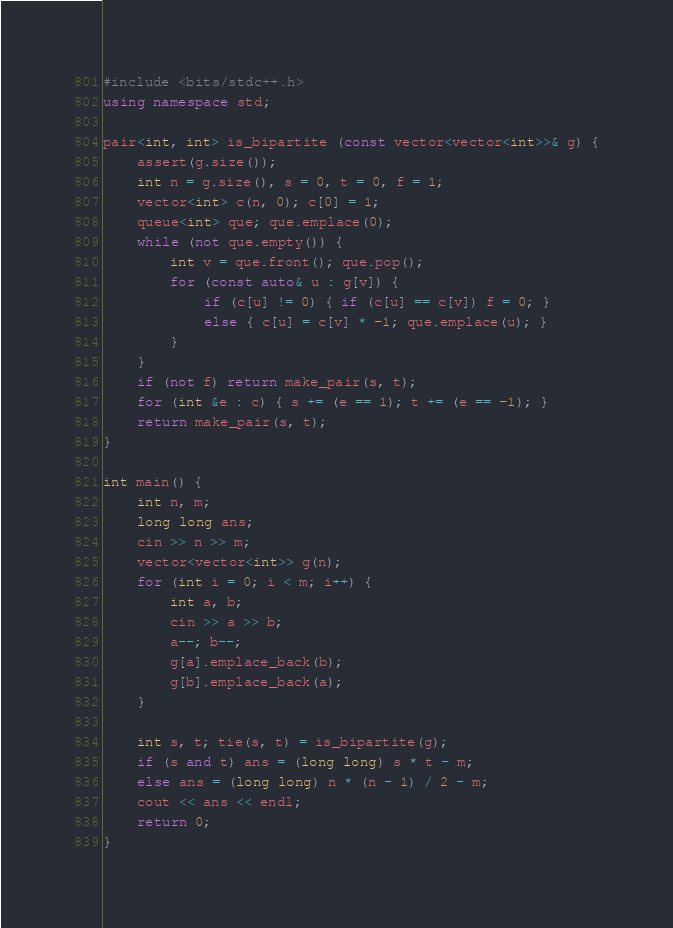Convert code to text. <code><loc_0><loc_0><loc_500><loc_500><_C++_>#include <bits/stdc++.h>
using namespace std;

pair<int, int> is_bipartite (const vector<vector<int>>& g) {
    assert(g.size());
    int n = g.size(), s = 0, t = 0, f = 1;
    vector<int> c(n, 0); c[0] = 1;
    queue<int> que; que.emplace(0);
    while (not que.empty()) {
        int v = que.front(); que.pop();
        for (const auto& u : g[v]) {
            if (c[u] != 0) { if (c[u] == c[v]) f = 0; }
            else { c[u] = c[v] * -1; que.emplace(u); }
        }
    }
    if (not f) return make_pair(s, t);
    for (int &e : c) { s += (e == 1); t += (e == -1); }
    return make_pair(s, t);
}

int main() {
    int n, m;
    long long ans;
    cin >> n >> m;
    vector<vector<int>> g(n);
    for (int i = 0; i < m; i++) {
        int a, b;
        cin >> a >> b;
        a--; b--;
        g[a].emplace_back(b);
        g[b].emplace_back(a);
    }
    
    int s, t; tie(s, t) = is_bipartite(g);
    if (s and t) ans = (long long) s * t - m;
    else ans = (long long) n * (n - 1) / 2 - m;
    cout << ans << endl;
    return 0;
}</code> 